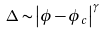<formula> <loc_0><loc_0><loc_500><loc_500>\Delta \sim \left | \phi - \phi _ { c } \right | ^ { \gamma }</formula> 